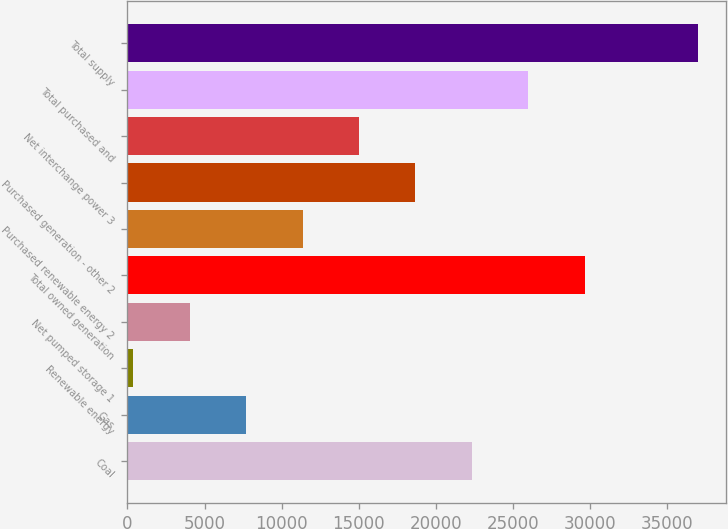Convert chart. <chart><loc_0><loc_0><loc_500><loc_500><bar_chart><fcel>Coal<fcel>Gas<fcel>Renewable energy<fcel>Net pumped storage 1<fcel>Total owned generation<fcel>Purchased renewable energy 2<fcel>Purchased generation - other 2<fcel>Net interchange power 3<fcel>Total purchased and<fcel>Total supply<nl><fcel>22340<fcel>7690<fcel>365<fcel>4027.5<fcel>29665<fcel>11352.5<fcel>18677.5<fcel>15015<fcel>26002.5<fcel>36990<nl></chart> 